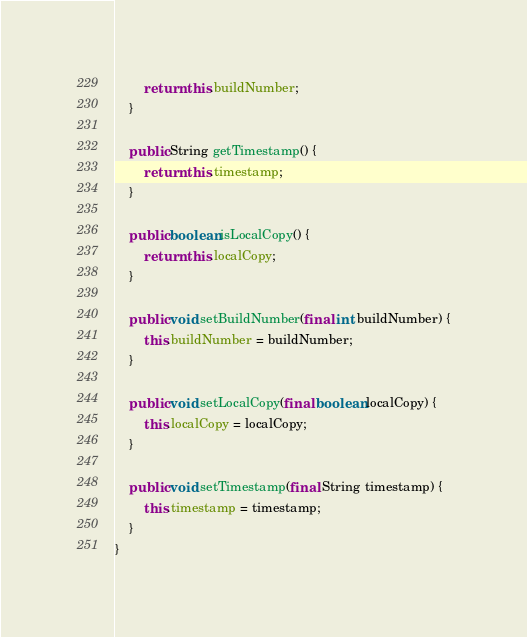<code> <loc_0><loc_0><loc_500><loc_500><_Java_>        return this.buildNumber;
    }
    
    public String getTimestamp() {
        return this.timestamp;
    }
    
    public boolean isLocalCopy() {
        return this.localCopy;
    }
    
    public void setBuildNumber(final int buildNumber) {
        this.buildNumber = buildNumber;
    }
    
    public void setLocalCopy(final boolean localCopy) {
        this.localCopy = localCopy;
    }
    
    public void setTimestamp(final String timestamp) {
        this.timestamp = timestamp;
    }
}
</code> 